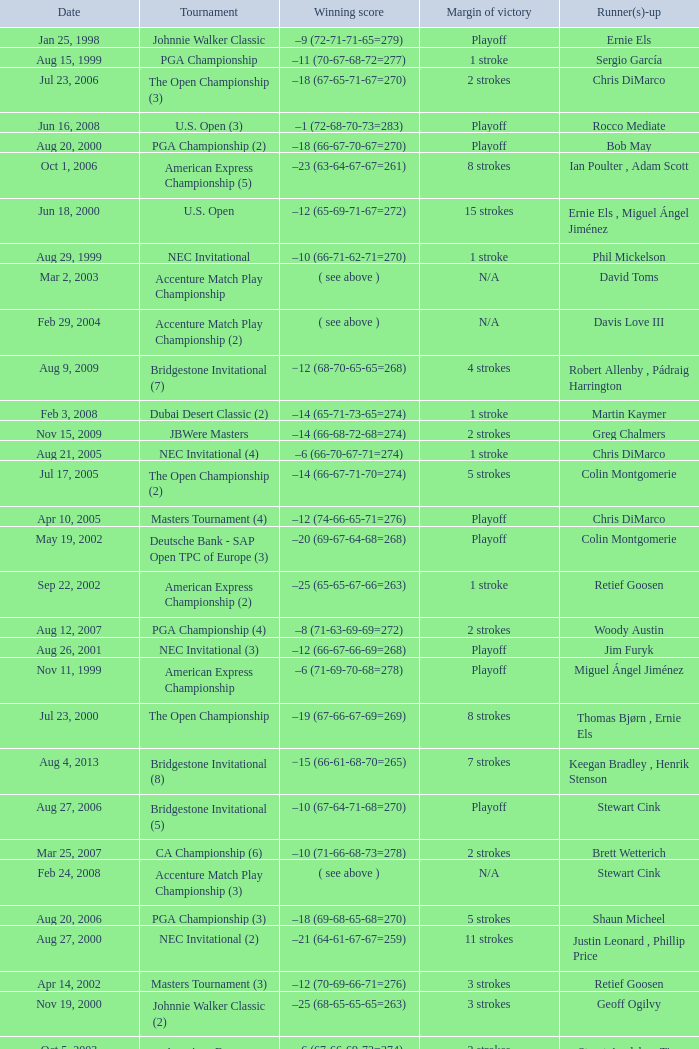Who has the Winning score of –10 (66-71-62-71=270) ? Phil Mickelson. 